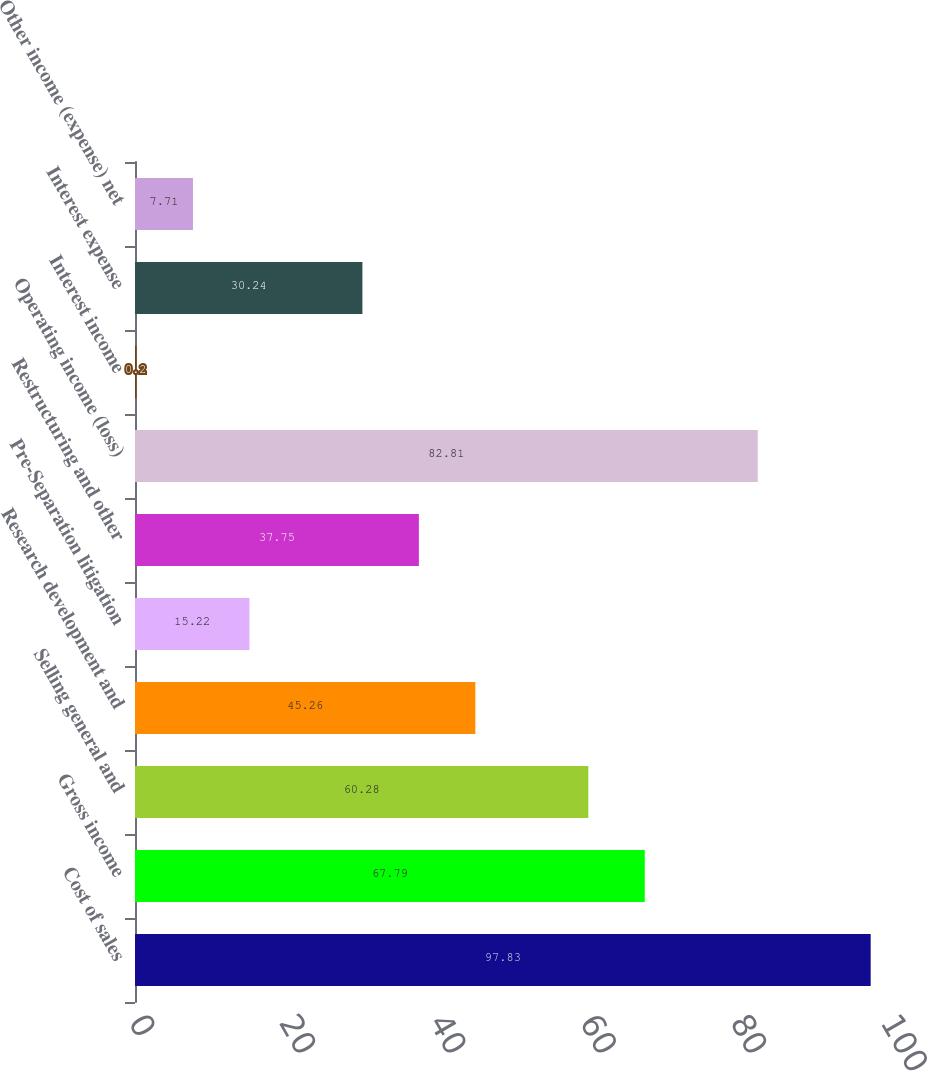<chart> <loc_0><loc_0><loc_500><loc_500><bar_chart><fcel>Cost of sales<fcel>Gross income<fcel>Selling general and<fcel>Research development and<fcel>Pre-Separation litigation<fcel>Restructuring and other<fcel>Operating income (loss)<fcel>Interest income<fcel>Interest expense<fcel>Other income (expense) net<nl><fcel>97.83<fcel>67.79<fcel>60.28<fcel>45.26<fcel>15.22<fcel>37.75<fcel>82.81<fcel>0.2<fcel>30.24<fcel>7.71<nl></chart> 